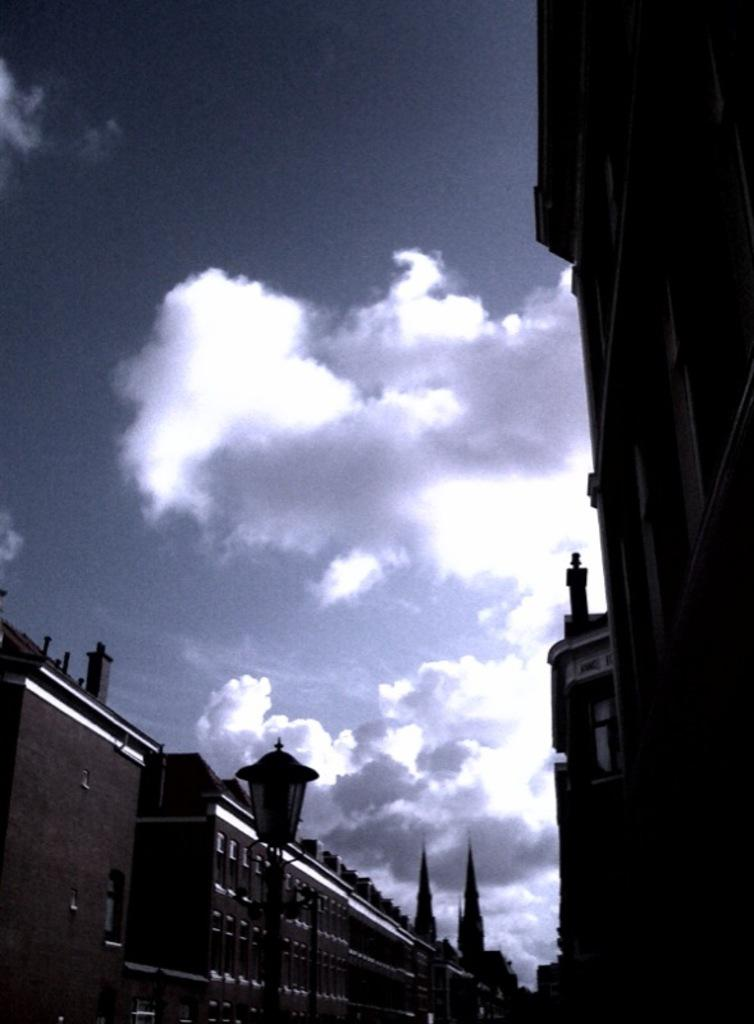What type of structures can be seen in the image? There are buildings in the image. What else can be seen in the image besides the buildings? There are light poles in the image. What is visible in the background of the image? The sky is visible in the image. What can be observed in the sky? Clouds are present in the sky. Can you hear the thunder in the image? There is no sound present in the image, so it is not possible to hear thunder. 